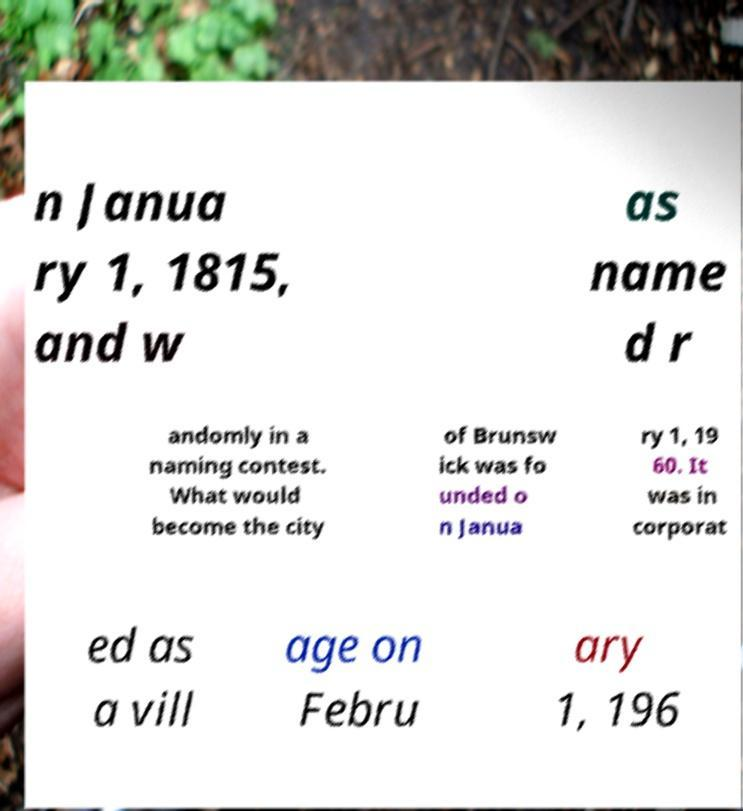Could you extract and type out the text from this image? n Janua ry 1, 1815, and w as name d r andomly in a naming contest. What would become the city of Brunsw ick was fo unded o n Janua ry 1, 19 60. It was in corporat ed as a vill age on Febru ary 1, 196 